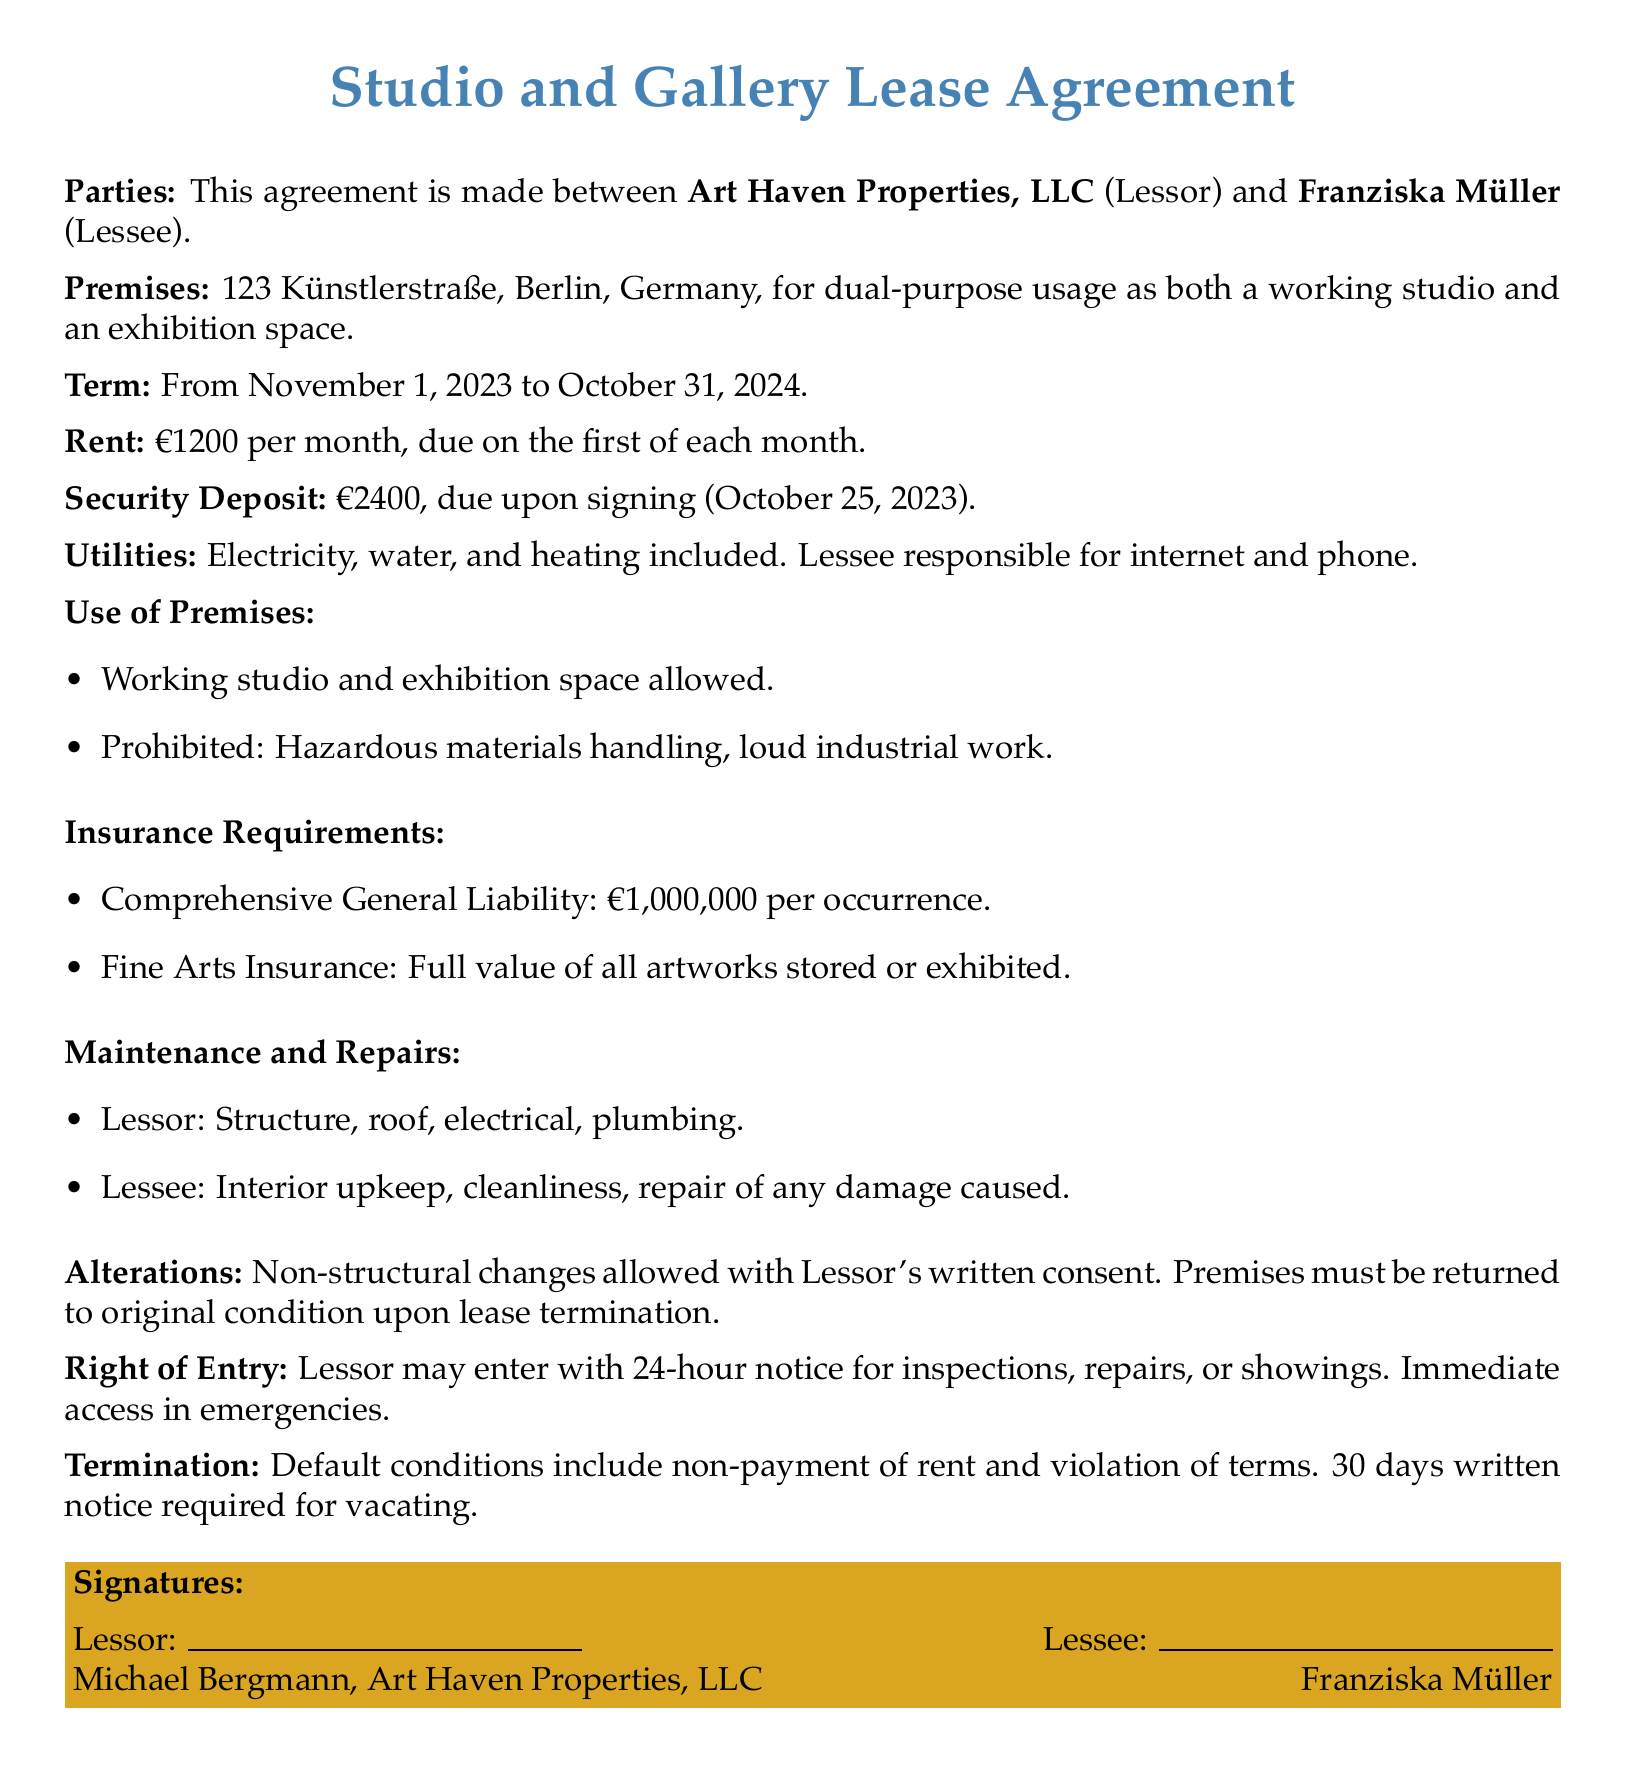What is the term of the lease? The term is specified in the agreement, starting from November 1, 2023, to October 31, 2024.
Answer: November 1, 2023 to October 31, 2024 Who is the lessee? The lessee is the individual or entity who is renting the premises, as identified in the document.
Answer: Franziska Müller What is the monthly rent? The document clearly states the monthly rent amount due for the lease.
Answer: €1200 What is the security deposit amount? The security deposit amount is indicated within the agreement as a required payment to be made upfront.
Answer: €2400 What type of insurance is required for artwork? The agreement outlines the type of insurance that the lessee must obtain for their artworks.
Answer: Fine Arts Insurance What utilities are included in the rent? The document specifies which utilities are covered under the rent and which ones are the lessee's responsibility.
Answer: Electricity, water, and heating How many days notice is required to vacate? The agreement states the notice period required for the lessee to inform the lessor when they plan to leave.
Answer: 30 days What are the prohibited activities in the premises? The agreement lists specific activities that are not allowed in the premises during the lease term.
Answer: Hazardous materials handling, loud industrial work What maintenance responsibilities does the lessee have? The document outlines the lessee's responsibilities regarding maintenance and upkeep within the premises.
Answer: Interior upkeep, cleanliness, repair of any damage caused 